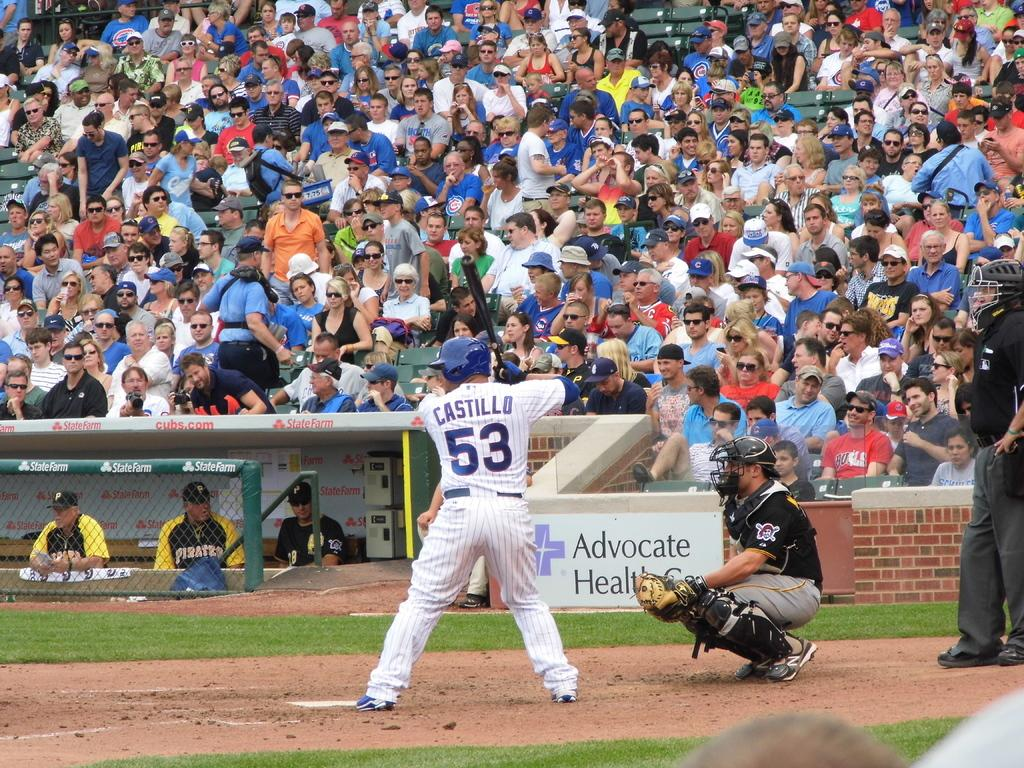<image>
Summarize the visual content of the image. Castillo is at bat an in position to swing at the ball. 